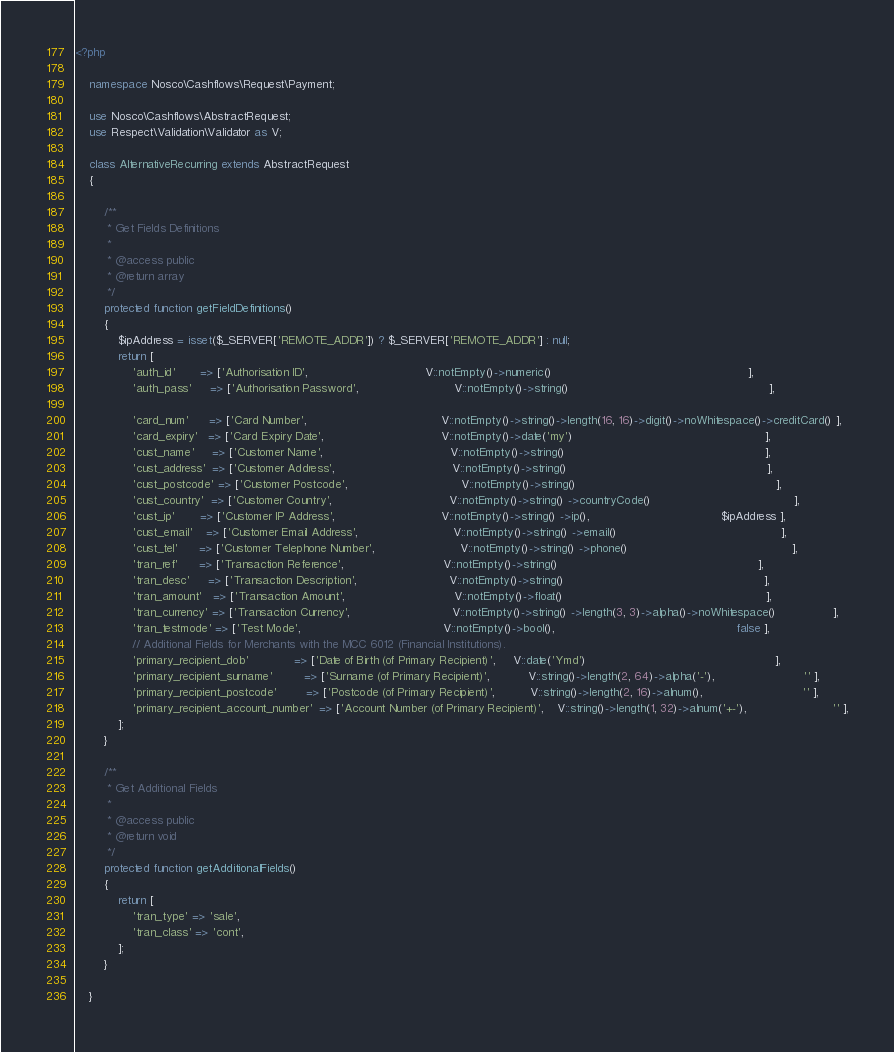Convert code to text. <code><loc_0><loc_0><loc_500><loc_500><_PHP_><?php

    namespace Nosco\Cashflows\Request\Payment;

    use Nosco\Cashflows\AbstractRequest;
    use Respect\Validation\Validator as V;

    class AlternativeRecurring extends AbstractRequest
    {

        /**
         * Get Fields Definitions
         *
         * @access public
         * @return array
         */
        protected function getFieldDefinitions()
        {
            $ipAddress = isset($_SERVER['REMOTE_ADDR']) ? $_SERVER['REMOTE_ADDR'] : null;
            return [
                'auth_id'       => ['Authorisation ID',                                 V::notEmpty()->numeric()                                                       ],
                'auth_pass'     => ['Authorisation Password',                           V::notEmpty()->string()                                                        ],

                'card_num'      => ['Card Number',                                      V::notEmpty()->string()->length(16, 16)->digit()->noWhitespace()->creditCard() ],
                'card_expiry'   => ['Card Expiry Date',                                 V::notEmpty()->date('my')                                                      ],
                'cust_name'     => ['Customer Name',                                    V::notEmpty()->string()                                                        ],
                'cust_address'  => ['Customer Address',                                 V::notEmpty()->string()                                                        ],
                'cust_postcode' => ['Customer Postcode',                                V::notEmpty()->string()                                                        ],
                'cust_country'  => ['Customer Country',                                 V::notEmpty()->string() ->countryCode()                                        ],
                'cust_ip'       => ['Customer IP Address',                              V::notEmpty()->string() ->ip(),                                     $ipAddress ],
                'cust_email'    => ['Customer Email Address',                           V::notEmpty()->string() ->email()                                              ],
                'cust_tel'      => ['Customer Telephone Number',                        V::notEmpty()->string() ->phone()                                              ],
                'tran_ref'      => ['Transaction Reference',                            V::notEmpty()->string()                                                        ],
                'tran_desc'     => ['Transaction Description',                          V::notEmpty()->string()                                                        ],
                'tran_amount'   => ['Transaction Amount',                               V::notEmpty()->float()                                                         ],
                'tran_currency' => ['Transaction Currency',                             V::notEmpty()->string() ->length(3, 3)->alpha()->noWhitespace()                ],
                'tran_testmode' => ['Test Mode',                                        V::notEmpty()->bool(),                                                   false ],
                // Additional Fields for Merchants with the MCC 6012 (Financial Institutions).
                'primary_recipient_dob'             => ['Date of Birth (of Primary Recipient)',     V::date('Ymd')                                                     ],
                'primary_recipient_surname'         => ['Surname (of Primary Recipient)',           V::string()->length(2, 64)->alpha('-'),                         '' ],
                'primary_recipient_postcode'        => ['Postcode (of Primary Recipient)',          V::string()->length(2, 16)->alnum(),                            '' ],
                'primary_recipient_account_number'  => ['Account Number (of Primary Recipient)',    V::string()->length(1, 32)->alnum('+-'),                        '' ],
            ];
        }

        /**
         * Get Additional Fields
         *
         * @access public
         * @return void
         */
        protected function getAdditionalFields()
        {
            return [
                'tran_type' => 'sale',
                'tran_class' => 'cont',
            ];
        }

    }
</code> 